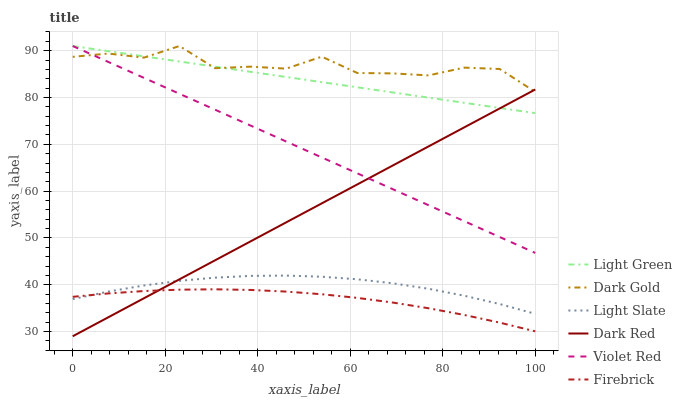Does Firebrick have the minimum area under the curve?
Answer yes or no. Yes. Does Dark Gold have the maximum area under the curve?
Answer yes or no. Yes. Does Light Slate have the minimum area under the curve?
Answer yes or no. No. Does Light Slate have the maximum area under the curve?
Answer yes or no. No. Is Violet Red the smoothest?
Answer yes or no. Yes. Is Dark Gold the roughest?
Answer yes or no. Yes. Is Light Slate the smoothest?
Answer yes or no. No. Is Light Slate the roughest?
Answer yes or no. No. Does Dark Red have the lowest value?
Answer yes or no. Yes. Does Light Slate have the lowest value?
Answer yes or no. No. Does Light Green have the highest value?
Answer yes or no. Yes. Does Light Slate have the highest value?
Answer yes or no. No. Is Light Slate less than Light Green?
Answer yes or no. Yes. Is Violet Red greater than Firebrick?
Answer yes or no. Yes. Does Violet Red intersect Dark Gold?
Answer yes or no. Yes. Is Violet Red less than Dark Gold?
Answer yes or no. No. Is Violet Red greater than Dark Gold?
Answer yes or no. No. Does Light Slate intersect Light Green?
Answer yes or no. No. 